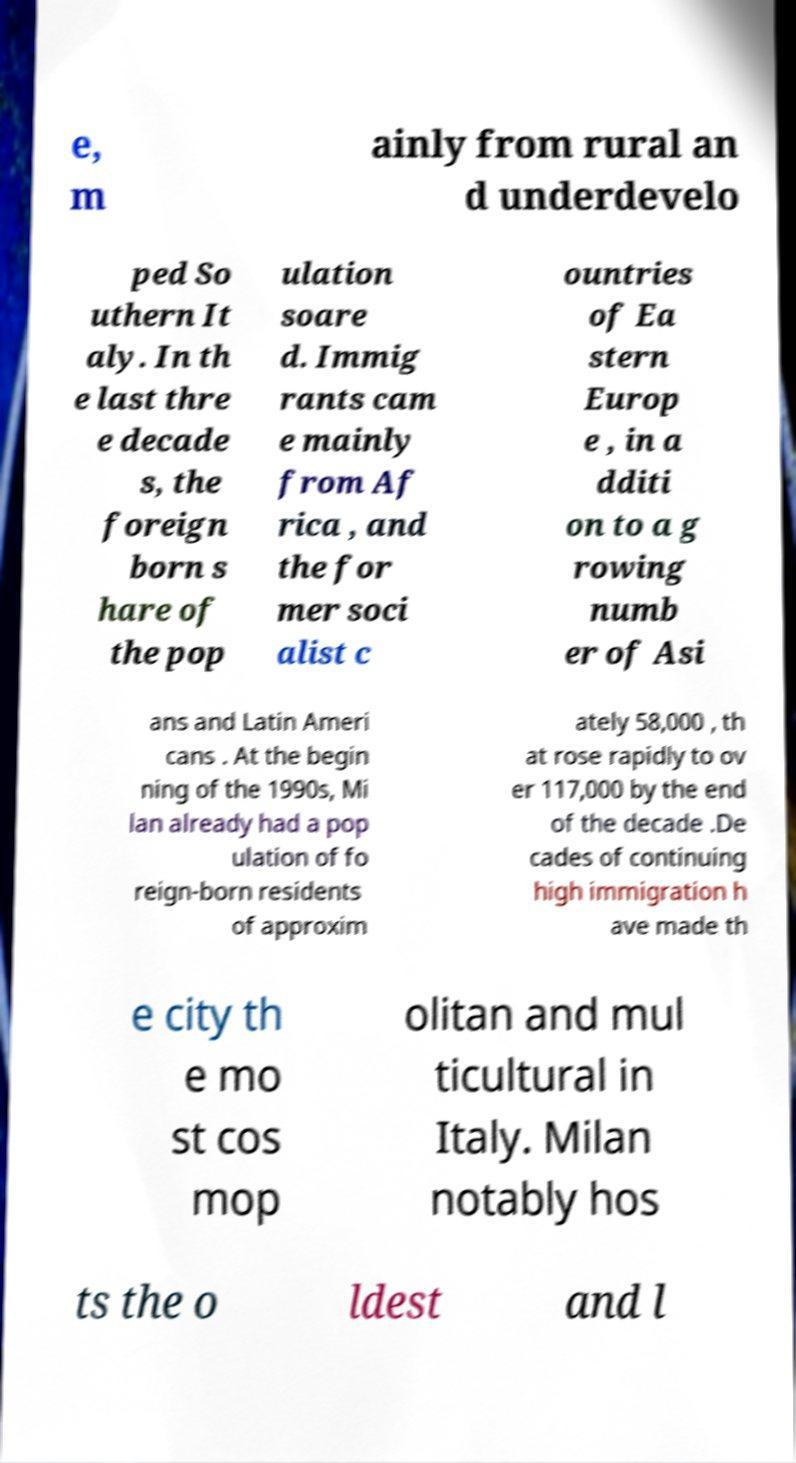Please identify and transcribe the text found in this image. e, m ainly from rural an d underdevelo ped So uthern It aly. In th e last thre e decade s, the foreign born s hare of the pop ulation soare d. Immig rants cam e mainly from Af rica , and the for mer soci alist c ountries of Ea stern Europ e , in a dditi on to a g rowing numb er of Asi ans and Latin Ameri cans . At the begin ning of the 1990s, Mi lan already had a pop ulation of fo reign-born residents of approxim ately 58,000 , th at rose rapidly to ov er 117,000 by the end of the decade .De cades of continuing high immigration h ave made th e city th e mo st cos mop olitan and mul ticultural in Italy. Milan notably hos ts the o ldest and l 